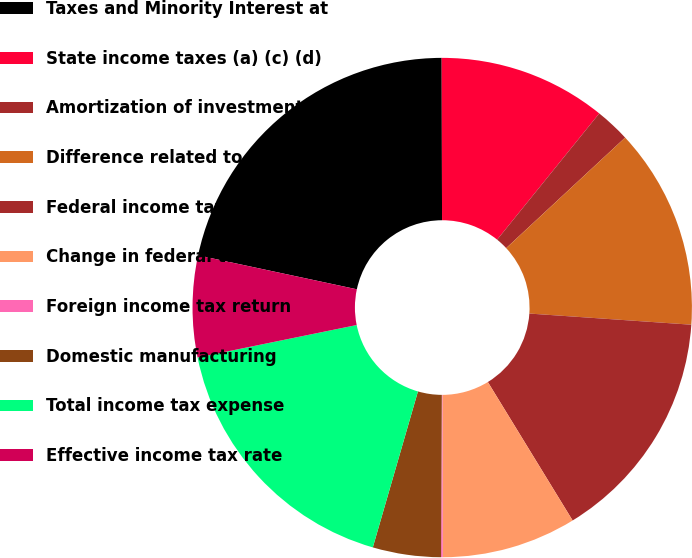Convert chart to OTSL. <chart><loc_0><loc_0><loc_500><loc_500><pie_chart><fcel>Taxes and Minority Interest at<fcel>State income taxes (a) (c) (d)<fcel>Amortization of investment tax<fcel>Difference related to income<fcel>Federal income tax credits (a)<fcel>Change in federal tax reserves<fcel>Foreign income tax return<fcel>Domestic manufacturing<fcel>Total income tax expense<fcel>Effective income tax rate<nl><fcel>21.61%<fcel>10.86%<fcel>2.26%<fcel>13.01%<fcel>15.16%<fcel>8.71%<fcel>0.11%<fcel>4.41%<fcel>17.31%<fcel>6.56%<nl></chart> 